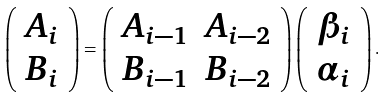<formula> <loc_0><loc_0><loc_500><loc_500>\left ( \begin{array} { c } A _ { i } \\ B _ { i } \end{array} \right ) = \left ( \begin{array} { c c } A _ { i - 1 } & A _ { i - 2 } \\ B _ { i - 1 } & B _ { i - 2 } \end{array} \right ) \left ( \begin{array} { c } \beta _ { i } \\ \alpha _ { i } \end{array} \right ) .</formula> 